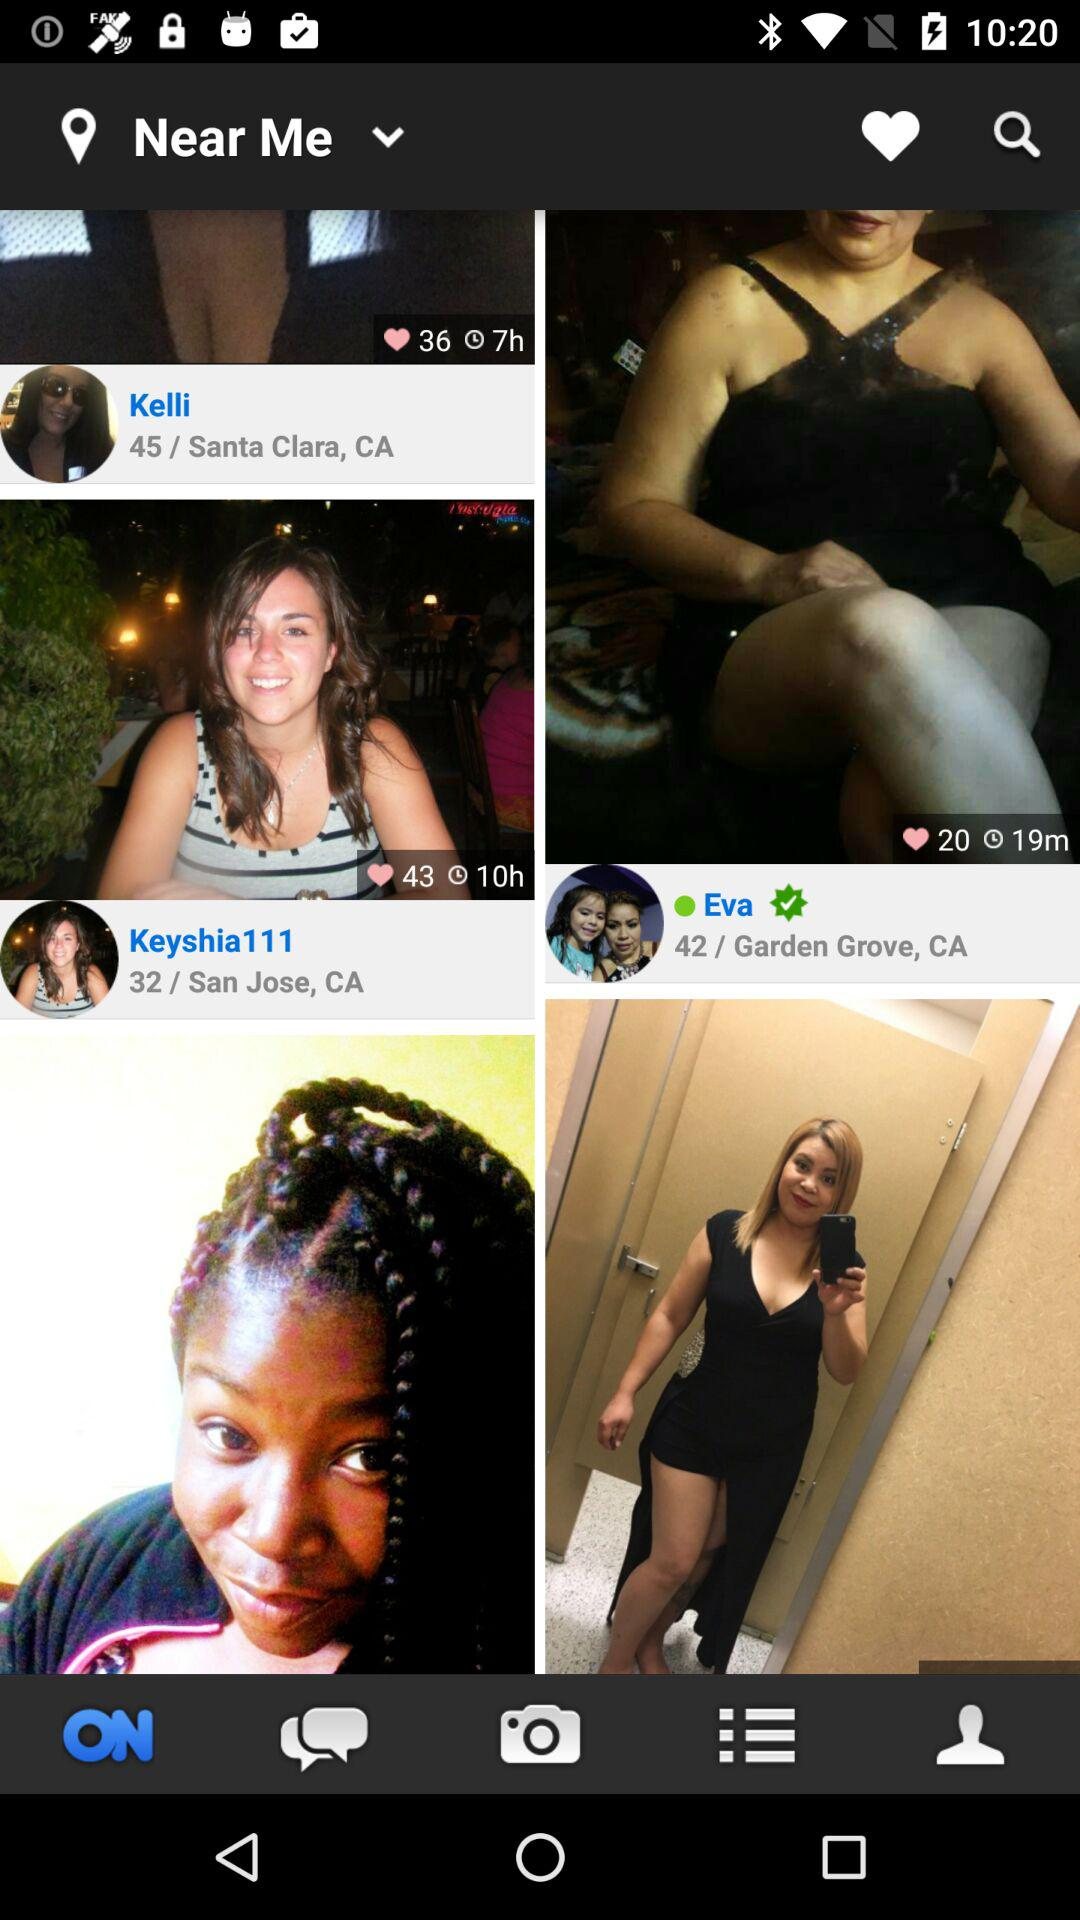How long ago did Eva post the picture? Eva posted the picture 19 minutes ago. 